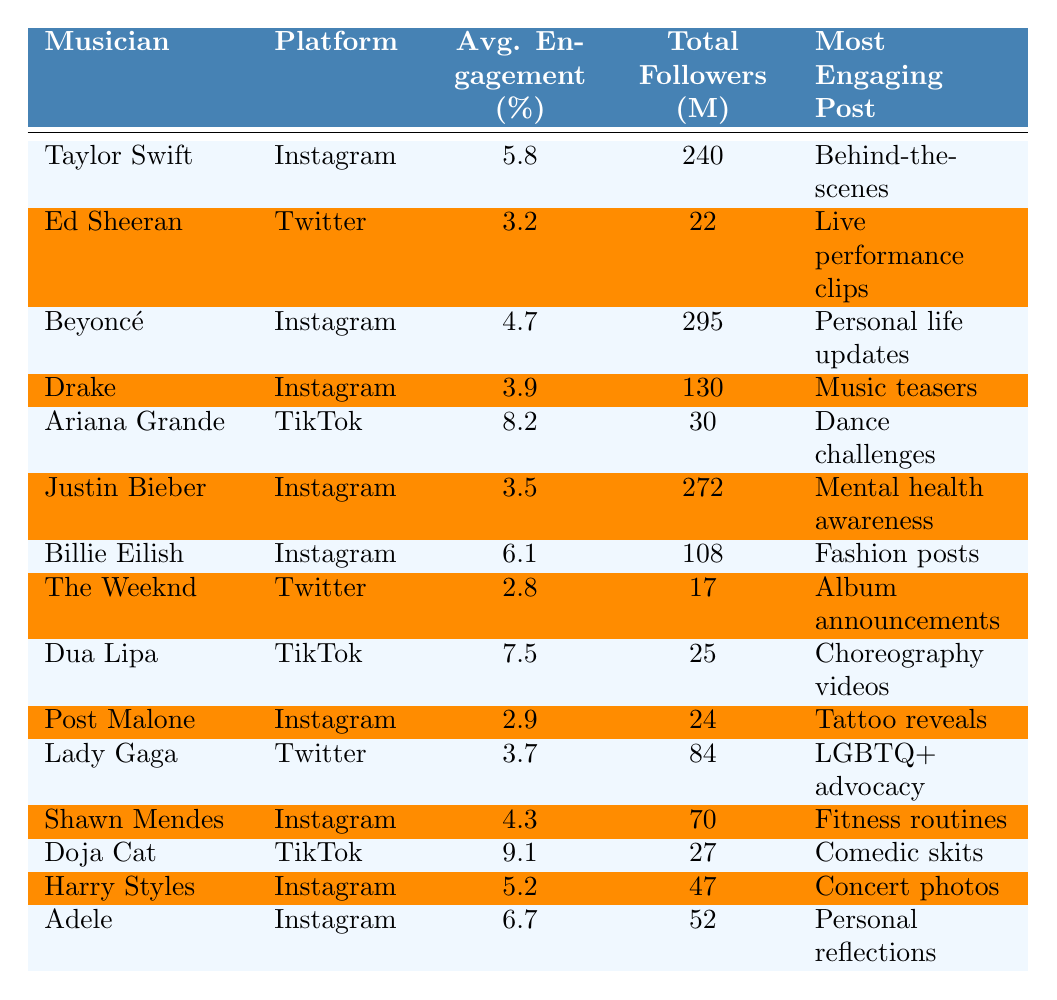What's the average engagement rate for Taylor Swift on Instagram? The table shows that Taylor Swift has an average engagement rate of 5.8% on Instagram.
Answer: 5.8% Which musician has the highest average engagement rate, and what platform do they use? Doja Cat has the highest average engagement rate at 9.1%, and she uses TikTok.
Answer: Doja Cat, TikTok How many total followers does Ariana Grande have? According to the table, Ariana Grande has a total of 30 million followers on TikTok.
Answer: 30 million What is the most engaging post type for Billie Eilish? The table states that Billie Eilish's most engaging post type is fashion posts.
Answer: Fashion posts Which platform has the lowest average engagement rate mentioned, and what is that rate? The table indicates that The Weeknd has the lowest average engagement rate at 2.8% on Twitter.
Answer: Twitter, 2.8% If you combine the total followers of Justin Bieber and Shawn Mendes, how many millions do you get? Justin Bieber has 272 million followers and Shawn Mendes has 70 million followers. So, 272 + 70 = 342 million followers in total.
Answer: 342 million Is it true that Beyoncé's average engagement rate is higher than that of Justin Bieber? Yes, Beyoncé has an engagement rate of 4.7%, while Justin Bieber's engagement rate is 3.5%.
Answer: Yes Which musician has a focus on mental health awareness and what is their engagement rate? Justin Bieber focuses on mental health awareness, and he has an engagement rate of 3.5%.
Answer: Justin Bieber, 3.5% What percentage of engagement does Adele have compared to Ariana Grande? Adele has 6.7% engagement, while Ariana Grande has 8.2%. The difference is 8.2 - 6.7 = 1.5%.
Answer: 1.5% Identify the musician who also engages in LGBTQ+ advocacy and mention their engagement rate. Lady Gaga is the musician who engages in LGBTQ+ advocacy, and her engagement rate is 3.7%.
Answer: Lady Gaga, 3.7% 